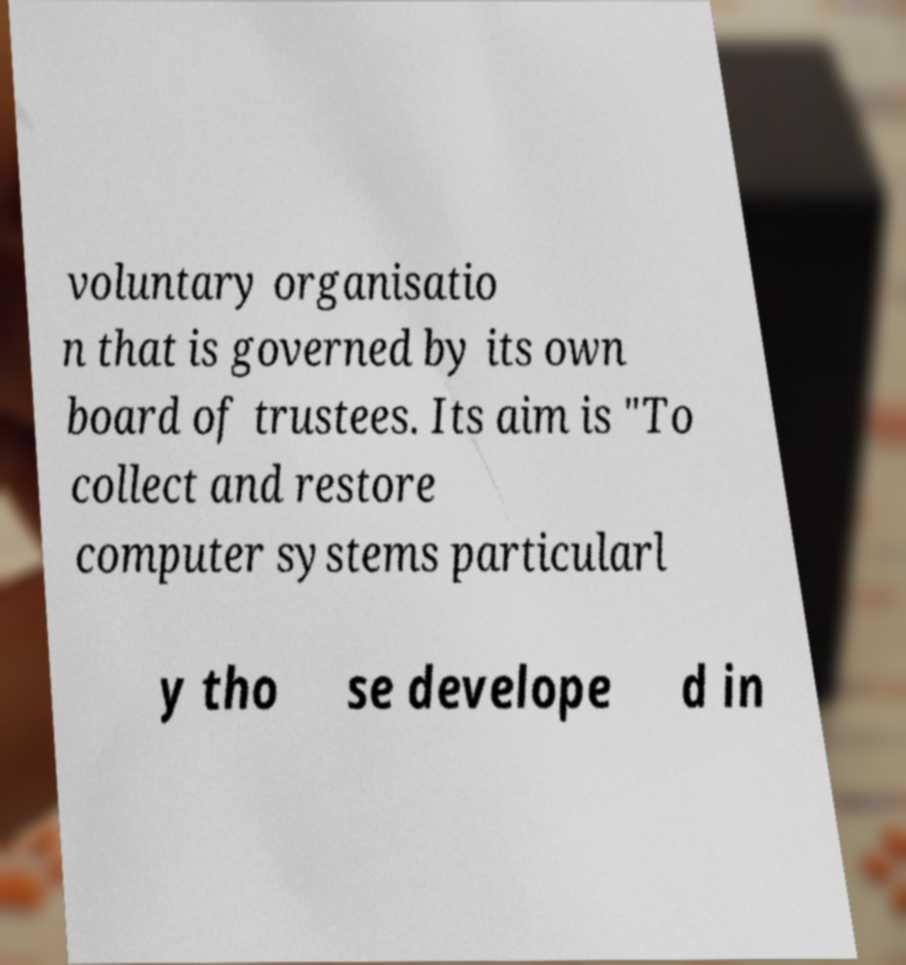What messages or text are displayed in this image? I need them in a readable, typed format. voluntary organisatio n that is governed by its own board of trustees. Its aim is "To collect and restore computer systems particularl y tho se develope d in 